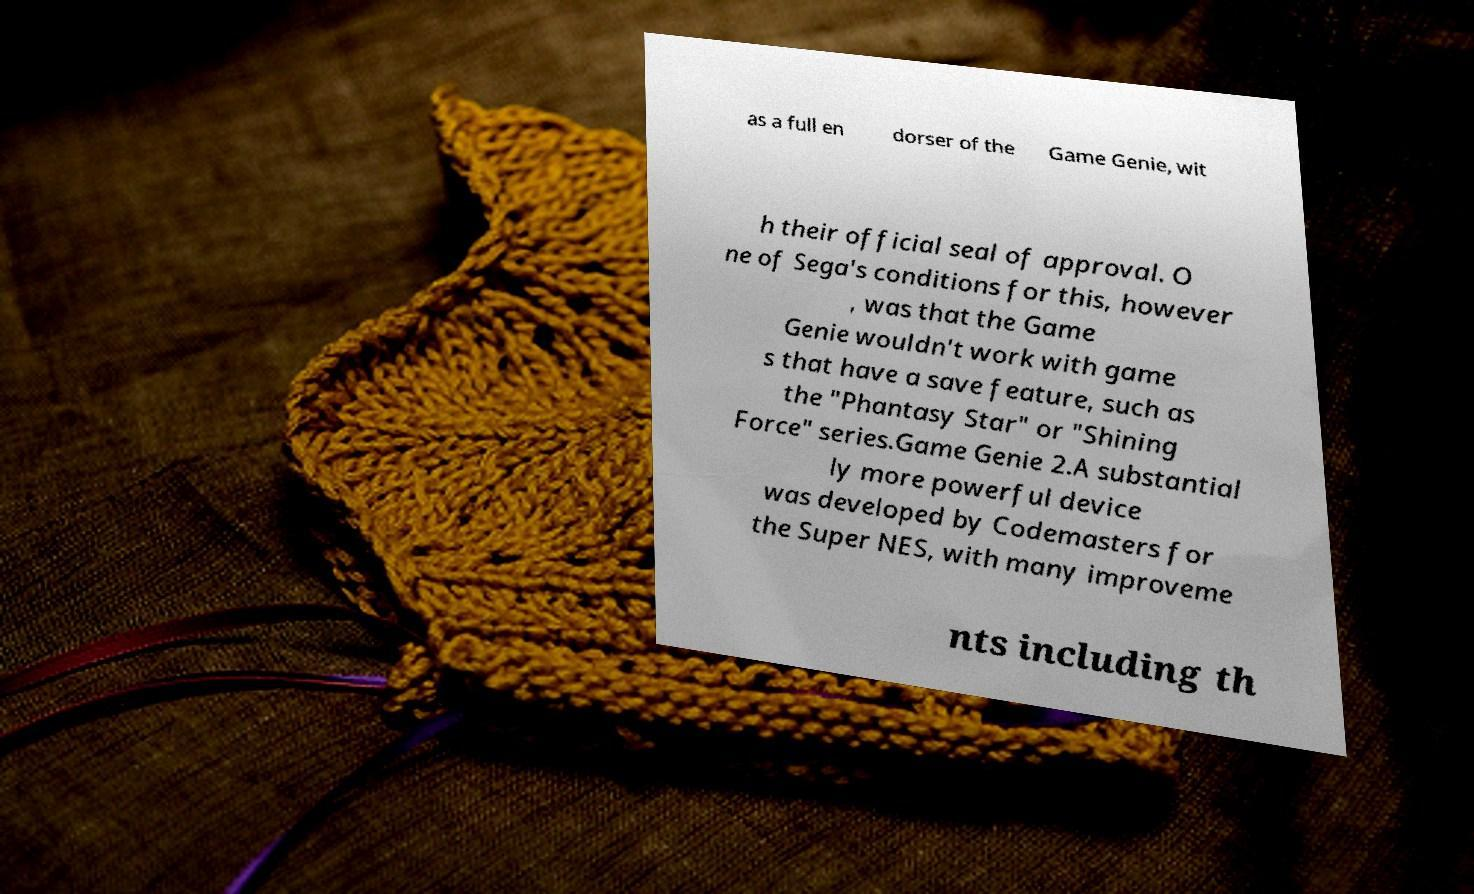What messages or text are displayed in this image? I need them in a readable, typed format. as a full en dorser of the Game Genie, wit h their official seal of approval. O ne of Sega's conditions for this, however , was that the Game Genie wouldn't work with game s that have a save feature, such as the "Phantasy Star" or "Shining Force" series.Game Genie 2.A substantial ly more powerful device was developed by Codemasters for the Super NES, with many improveme nts including th 